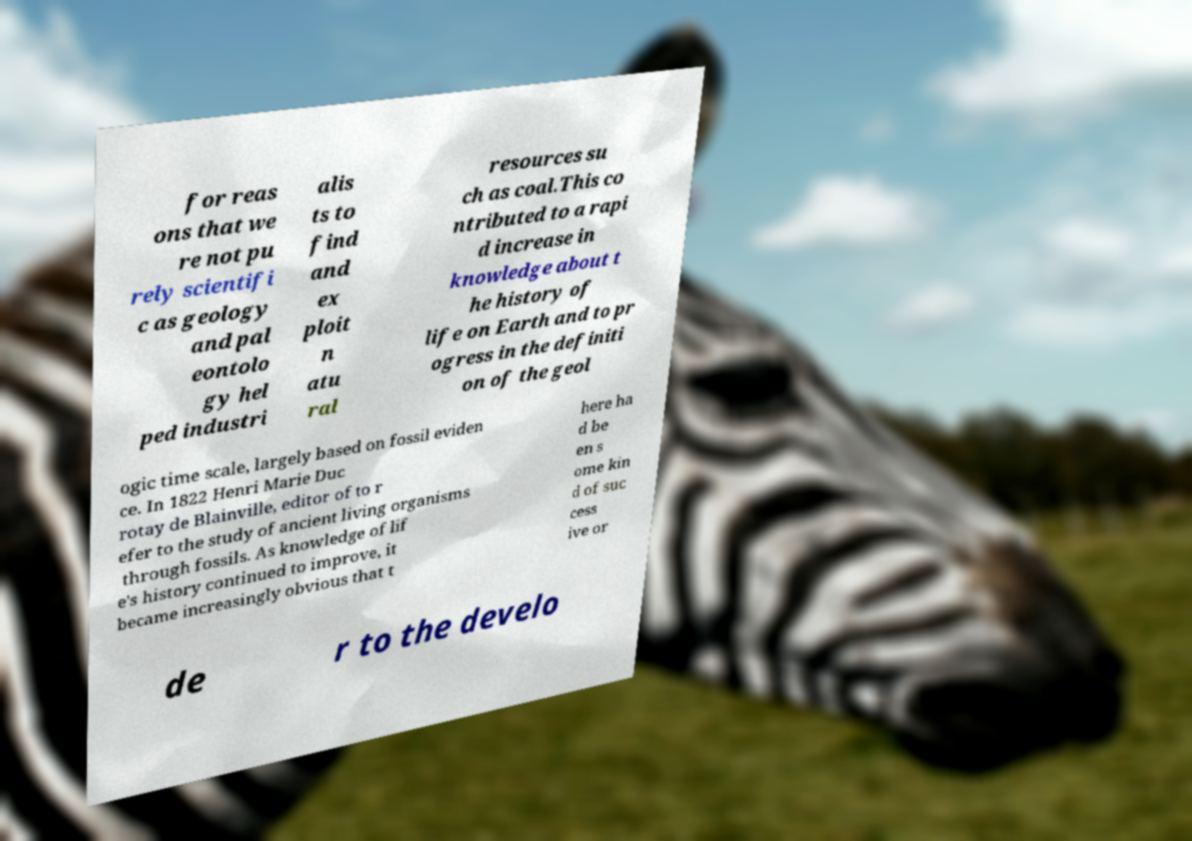Can you accurately transcribe the text from the provided image for me? for reas ons that we re not pu rely scientifi c as geology and pal eontolo gy hel ped industri alis ts to find and ex ploit n atu ral resources su ch as coal.This co ntributed to a rapi d increase in knowledge about t he history of life on Earth and to pr ogress in the definiti on of the geol ogic time scale, largely based on fossil eviden ce. In 1822 Henri Marie Duc rotay de Blainville, editor of to r efer to the study of ancient living organisms through fossils. As knowledge of lif e's history continued to improve, it became increasingly obvious that t here ha d be en s ome kin d of suc cess ive or de r to the develo 